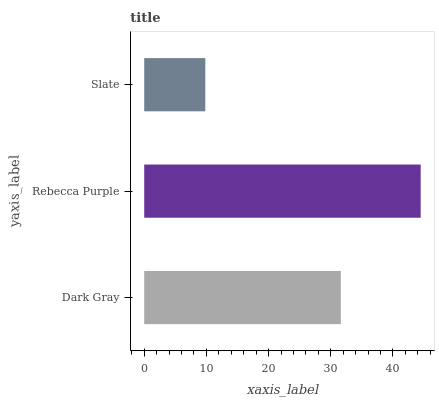Is Slate the minimum?
Answer yes or no. Yes. Is Rebecca Purple the maximum?
Answer yes or no. Yes. Is Rebecca Purple the minimum?
Answer yes or no. No. Is Slate the maximum?
Answer yes or no. No. Is Rebecca Purple greater than Slate?
Answer yes or no. Yes. Is Slate less than Rebecca Purple?
Answer yes or no. Yes. Is Slate greater than Rebecca Purple?
Answer yes or no. No. Is Rebecca Purple less than Slate?
Answer yes or no. No. Is Dark Gray the high median?
Answer yes or no. Yes. Is Dark Gray the low median?
Answer yes or no. Yes. Is Rebecca Purple the high median?
Answer yes or no. No. Is Slate the low median?
Answer yes or no. No. 